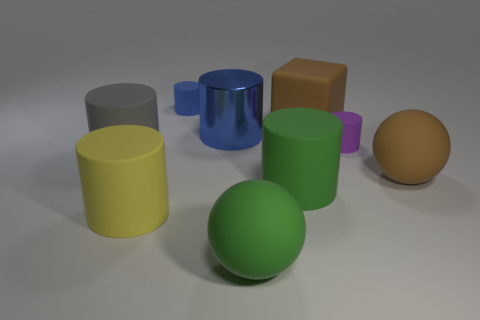Subtract all green cylinders. How many cylinders are left? 5 Subtract all blue cylinders. How many cylinders are left? 4 Subtract 2 cylinders. How many cylinders are left? 4 Subtract all green cylinders. Subtract all brown spheres. How many cylinders are left? 5 Add 1 small cyan cubes. How many objects exist? 10 Subtract all blocks. How many objects are left? 8 Add 7 yellow things. How many yellow things exist? 8 Subtract 0 red cylinders. How many objects are left? 9 Subtract all large gray cylinders. Subtract all spheres. How many objects are left? 6 Add 4 big yellow rubber cylinders. How many big yellow rubber cylinders are left? 5 